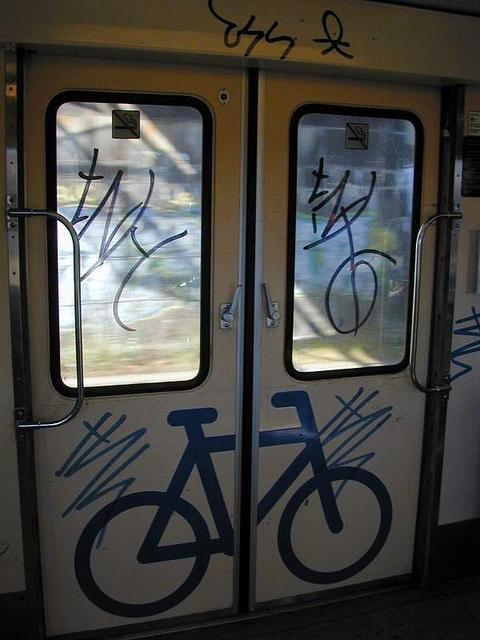How many wheels are drawn on the door?
Give a very brief answer. 2. 